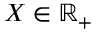<formula> <loc_0><loc_0><loc_500><loc_500>X \in \mathbb { R } _ { + }</formula> 